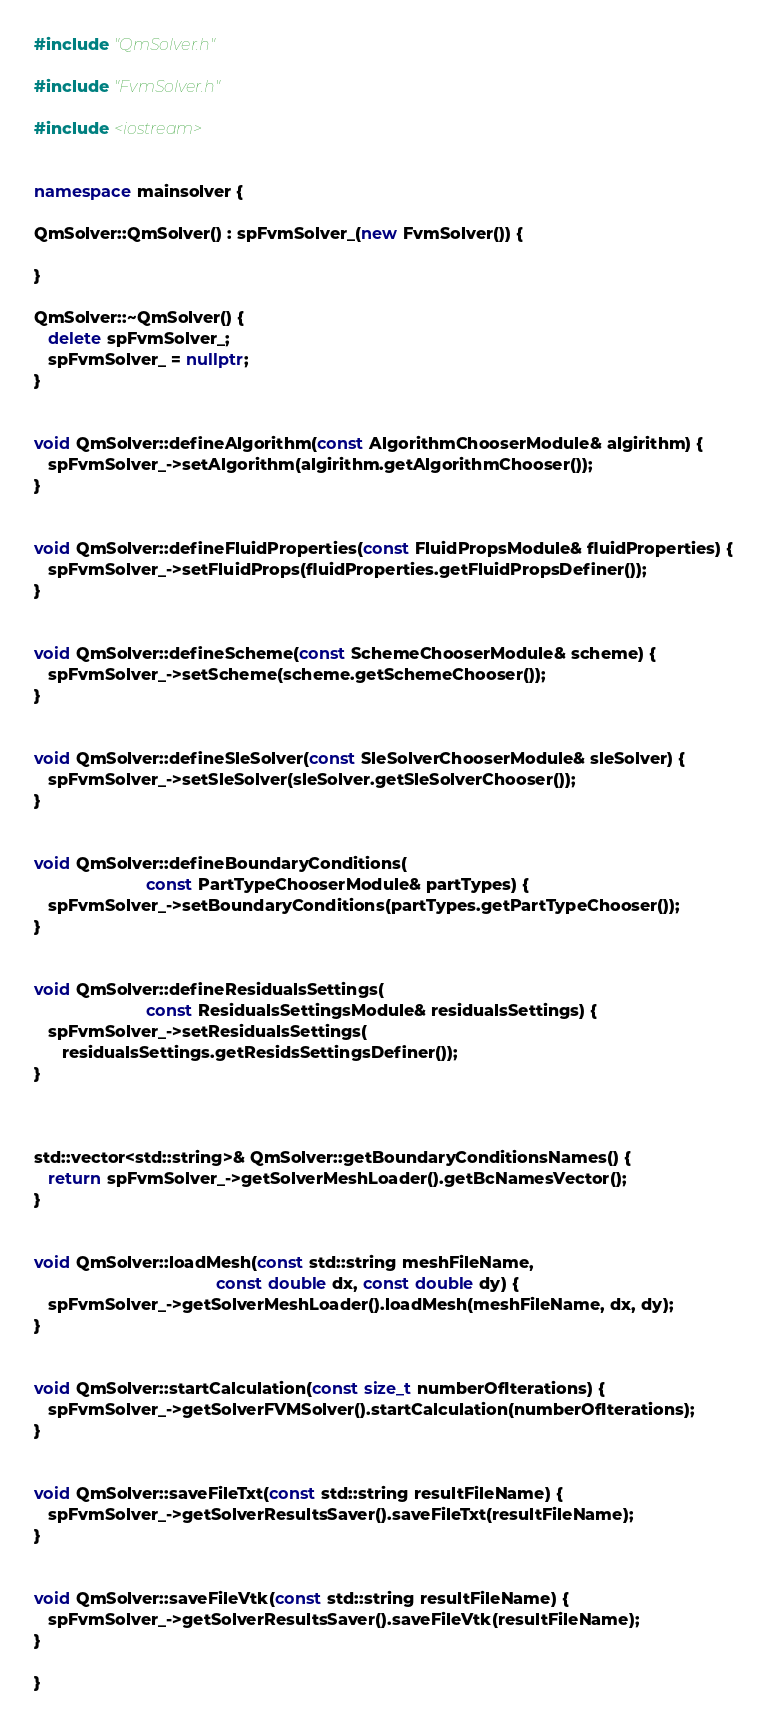<code> <loc_0><loc_0><loc_500><loc_500><_C++_>#include "QmSolver.h"

#include "FvmSolver.h"

#include <iostream>


namespace mainsolver {

QmSolver::QmSolver() : spFvmSolver_(new FvmSolver()) {

}

QmSolver::~QmSolver() {
   delete spFvmSolver_;
   spFvmSolver_ = nullptr;
}


void QmSolver::defineAlgorithm(const AlgorithmChooserModule& algirithm) {
   spFvmSolver_->setAlgorithm(algirithm.getAlgorithmChooser());
}


void QmSolver::defineFluidProperties(const FluidPropsModule& fluidProperties) {
   spFvmSolver_->setFluidProps(fluidProperties.getFluidPropsDefiner());
}


void QmSolver::defineScheme(const SchemeChooserModule& scheme) {
   spFvmSolver_->setScheme(scheme.getSchemeChooser());
}


void QmSolver::defineSleSolver(const SleSolverChooserModule& sleSolver) {
   spFvmSolver_->setSleSolver(sleSolver.getSleSolverChooser());
}


void QmSolver::defineBoundaryConditions(
                        const PartTypeChooserModule& partTypes) {
   spFvmSolver_->setBoundaryConditions(partTypes.getPartTypeChooser());
}


void QmSolver::defineResidualsSettings(
                        const ResidualsSettingsModule& residualsSettings) {
   spFvmSolver_->setResidualsSettings(
      residualsSettings.getResidsSettingsDefiner());
}



std::vector<std::string>& QmSolver::getBoundaryConditionsNames() {
   return spFvmSolver_->getSolverMeshLoader().getBcNamesVector();
}


void QmSolver::loadMesh(const std::string meshFileName, 
                                       const double dx, const double dy) {
   spFvmSolver_->getSolverMeshLoader().loadMesh(meshFileName, dx, dy);
}


void QmSolver::startCalculation(const size_t numberOfIterations) {
   spFvmSolver_->getSolverFVMSolver().startCalculation(numberOfIterations);
}


void QmSolver::saveFileTxt(const std::string resultFileName) {
   spFvmSolver_->getSolverResultsSaver().saveFileTxt(resultFileName);
}


void QmSolver::saveFileVtk(const std::string resultFileName) {
   spFvmSolver_->getSolverResultsSaver().saveFileVtk(resultFileName);
}

}</code> 